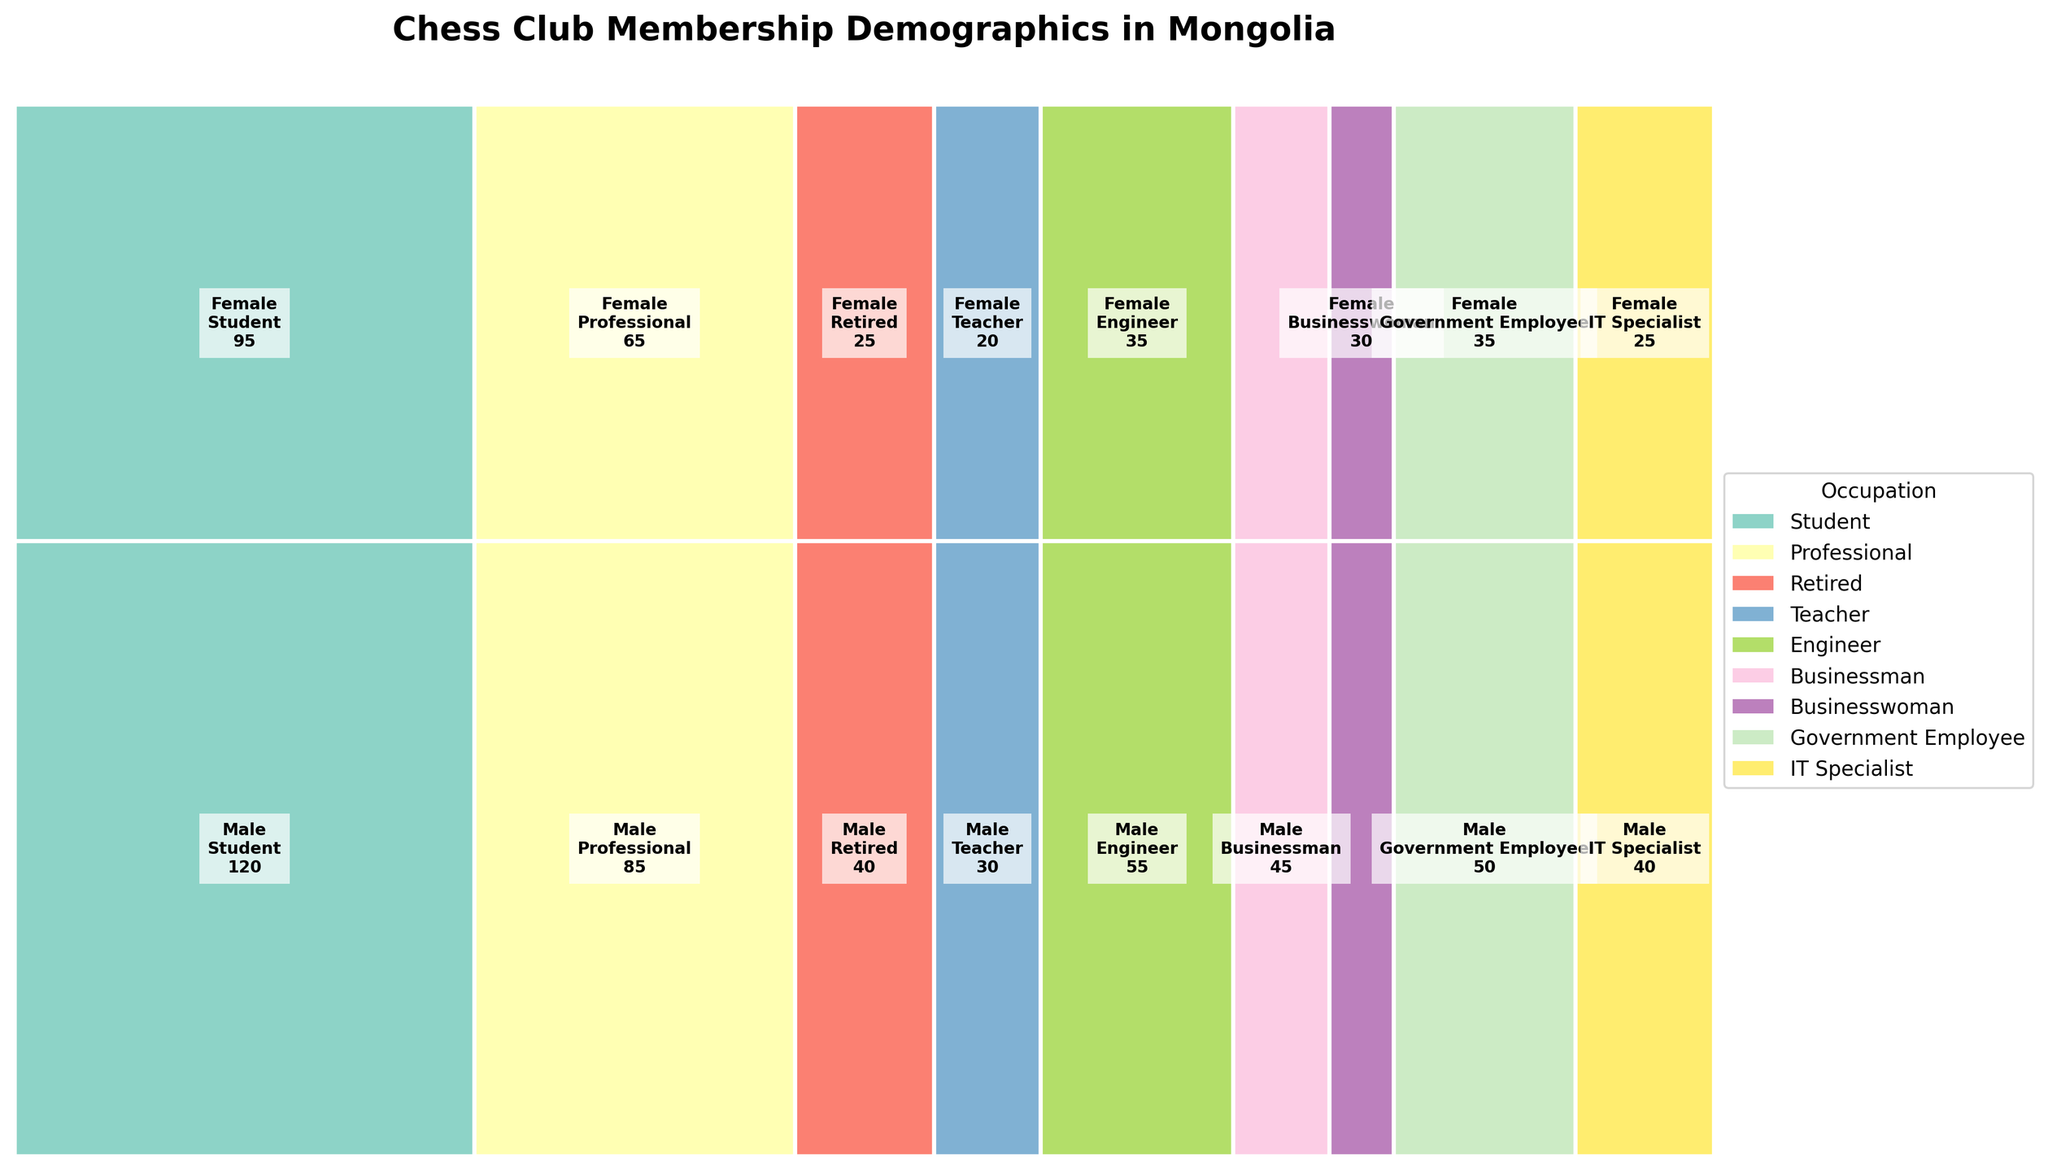What is the title of the mosaic plot? The title of the mosaic plot is usually displayed at the top of the figure. In this case, it is given in the code as the title parameter in the plt.title function.
Answer: Chess Club Membership Demographics in Mongolia Which occupation has the highest membership count among males? To find this, look for the largest rectangle in the section labeled 'Male'. Compare the sizes of rectangles associated with different occupations.
Answer: Student How many female teachers are there in the chess club? Look for the rectangle labeled 'Female' and 'Teacher'. The count is indicated within the rectangle.
Answer: 20 Which gender has a higher total membership in the chess club? Sum the membership counts for all occupations within each gender section. From the data, sum the counts for 'Male' and 'Female' separately and compare.
Answer: Male What is the membership count for female IT Specialists? Locate the rectangle in the 'Female' section labeled 'IT Specialist'. The count is displayed inside the rectangle.
Answer: 25 Which gender has a higher number of retired members? Compare the rectangles for 'Retired' in both the 'Male' and 'Female' sections.
Answer: Male What percentage of the total chess club membership is made up by male students? First, find the count of male students (120). Then, sum the total counts (665). The percentage is (120 / 665) * 100.
Answer: Approximately 18.05% Compare the number of male and female government employees. Which group is larger? Find the rectangles for 'Government Employee' in both gender sections and compare their counts.
Answer: Male What is the most common occupation among female members? Compare the sizes of the rectangles within the 'Female' section to find the largest one.
Answer: Student For which occupation is there the smallest difference between male and female membership counts? Calculate the absolute differences between male and female counts for each occupation and identify the smallest one. Detailed calculations are: Student (25), Professional (20), Retired (15), Teacher (10), Engineer (20), Businessman/Businesswoman (15), Government Employee (15), IT Specialist (15).
Answer: Teacher 